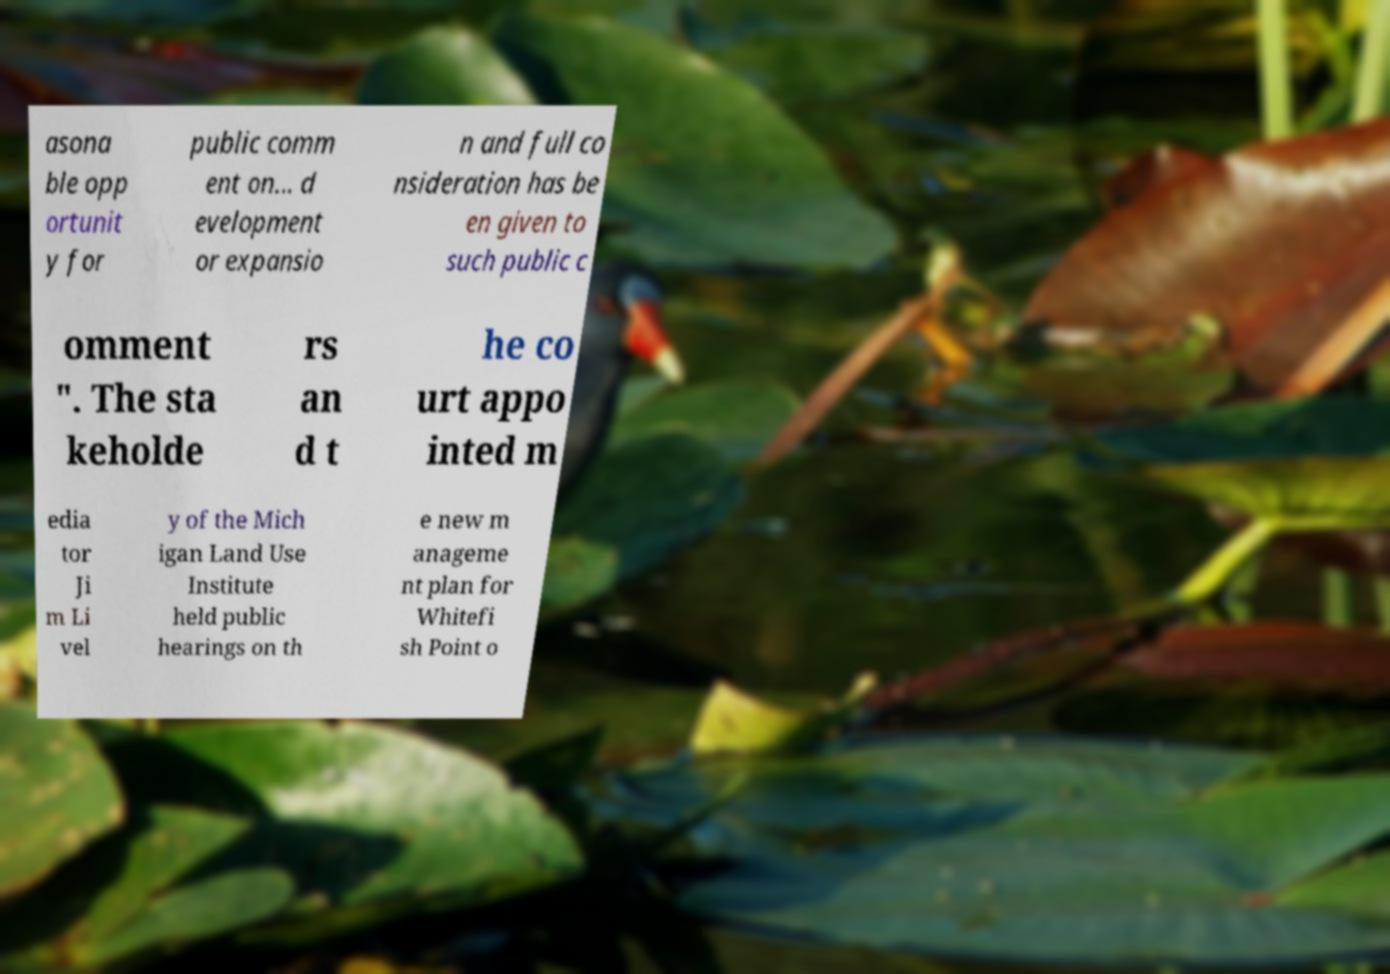Can you accurately transcribe the text from the provided image for me? asona ble opp ortunit y for public comm ent on... d evelopment or expansio n and full co nsideration has be en given to such public c omment ". The sta keholde rs an d t he co urt appo inted m edia tor Ji m Li vel y of the Mich igan Land Use Institute held public hearings on th e new m anageme nt plan for Whitefi sh Point o 